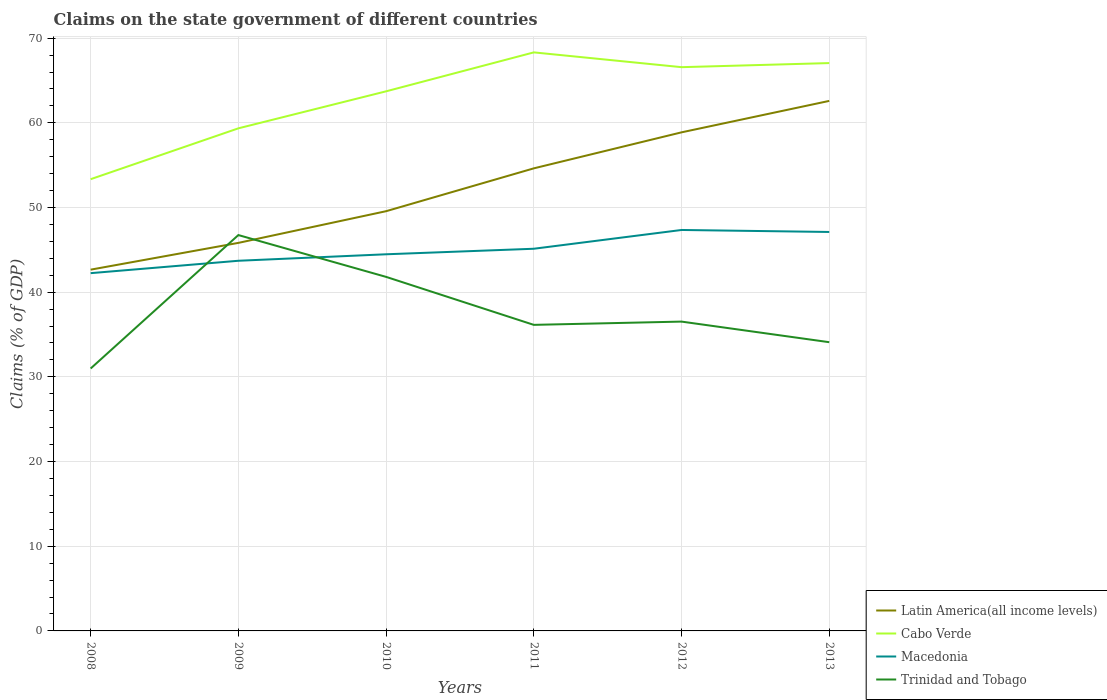Does the line corresponding to Trinidad and Tobago intersect with the line corresponding to Latin America(all income levels)?
Your response must be concise. Yes. Across all years, what is the maximum percentage of GDP claimed on the state government in Latin America(all income levels)?
Provide a succinct answer. 42.66. In which year was the percentage of GDP claimed on the state government in Macedonia maximum?
Give a very brief answer. 2008. What is the total percentage of GDP claimed on the state government in Cabo Verde in the graph?
Offer a very short reply. -14.98. What is the difference between the highest and the second highest percentage of GDP claimed on the state government in Trinidad and Tobago?
Offer a terse response. 15.76. How many years are there in the graph?
Keep it short and to the point. 6. What is the difference between two consecutive major ticks on the Y-axis?
Ensure brevity in your answer.  10. Are the values on the major ticks of Y-axis written in scientific E-notation?
Make the answer very short. No. Does the graph contain grids?
Provide a succinct answer. Yes. Where does the legend appear in the graph?
Your answer should be compact. Bottom right. How many legend labels are there?
Provide a short and direct response. 4. How are the legend labels stacked?
Provide a short and direct response. Vertical. What is the title of the graph?
Offer a very short reply. Claims on the state government of different countries. What is the label or title of the Y-axis?
Provide a succinct answer. Claims (% of GDP). What is the Claims (% of GDP) in Latin America(all income levels) in 2008?
Your response must be concise. 42.66. What is the Claims (% of GDP) of Cabo Verde in 2008?
Your answer should be compact. 53.34. What is the Claims (% of GDP) of Macedonia in 2008?
Provide a succinct answer. 42.25. What is the Claims (% of GDP) in Trinidad and Tobago in 2008?
Your answer should be very brief. 30.99. What is the Claims (% of GDP) of Latin America(all income levels) in 2009?
Your answer should be very brief. 45.82. What is the Claims (% of GDP) in Cabo Verde in 2009?
Offer a terse response. 59.35. What is the Claims (% of GDP) of Macedonia in 2009?
Your answer should be compact. 43.71. What is the Claims (% of GDP) in Trinidad and Tobago in 2009?
Give a very brief answer. 46.75. What is the Claims (% of GDP) in Latin America(all income levels) in 2010?
Ensure brevity in your answer.  49.56. What is the Claims (% of GDP) in Cabo Verde in 2010?
Provide a short and direct response. 63.72. What is the Claims (% of GDP) of Macedonia in 2010?
Provide a short and direct response. 44.48. What is the Claims (% of GDP) in Trinidad and Tobago in 2010?
Make the answer very short. 41.81. What is the Claims (% of GDP) of Latin America(all income levels) in 2011?
Your answer should be very brief. 54.62. What is the Claims (% of GDP) in Cabo Verde in 2011?
Offer a very short reply. 68.32. What is the Claims (% of GDP) in Macedonia in 2011?
Provide a short and direct response. 45.13. What is the Claims (% of GDP) in Trinidad and Tobago in 2011?
Make the answer very short. 36.14. What is the Claims (% of GDP) in Latin America(all income levels) in 2012?
Make the answer very short. 58.88. What is the Claims (% of GDP) of Cabo Verde in 2012?
Your answer should be compact. 66.57. What is the Claims (% of GDP) in Macedonia in 2012?
Provide a short and direct response. 47.35. What is the Claims (% of GDP) in Trinidad and Tobago in 2012?
Your answer should be very brief. 36.53. What is the Claims (% of GDP) of Latin America(all income levels) in 2013?
Give a very brief answer. 62.59. What is the Claims (% of GDP) of Cabo Verde in 2013?
Ensure brevity in your answer.  67.05. What is the Claims (% of GDP) in Macedonia in 2013?
Keep it short and to the point. 47.11. What is the Claims (% of GDP) in Trinidad and Tobago in 2013?
Keep it short and to the point. 34.09. Across all years, what is the maximum Claims (% of GDP) of Latin America(all income levels)?
Provide a short and direct response. 62.59. Across all years, what is the maximum Claims (% of GDP) of Cabo Verde?
Make the answer very short. 68.32. Across all years, what is the maximum Claims (% of GDP) in Macedonia?
Offer a very short reply. 47.35. Across all years, what is the maximum Claims (% of GDP) of Trinidad and Tobago?
Your response must be concise. 46.75. Across all years, what is the minimum Claims (% of GDP) of Latin America(all income levels)?
Ensure brevity in your answer.  42.66. Across all years, what is the minimum Claims (% of GDP) in Cabo Verde?
Ensure brevity in your answer.  53.34. Across all years, what is the minimum Claims (% of GDP) of Macedonia?
Offer a very short reply. 42.25. Across all years, what is the minimum Claims (% of GDP) in Trinidad and Tobago?
Give a very brief answer. 30.99. What is the total Claims (% of GDP) in Latin America(all income levels) in the graph?
Your response must be concise. 314.14. What is the total Claims (% of GDP) of Cabo Verde in the graph?
Keep it short and to the point. 378.35. What is the total Claims (% of GDP) of Macedonia in the graph?
Provide a succinct answer. 270.02. What is the total Claims (% of GDP) of Trinidad and Tobago in the graph?
Your answer should be compact. 226.3. What is the difference between the Claims (% of GDP) of Latin America(all income levels) in 2008 and that in 2009?
Your answer should be compact. -3.16. What is the difference between the Claims (% of GDP) in Cabo Verde in 2008 and that in 2009?
Offer a very short reply. -6.01. What is the difference between the Claims (% of GDP) of Macedonia in 2008 and that in 2009?
Offer a very short reply. -1.46. What is the difference between the Claims (% of GDP) in Trinidad and Tobago in 2008 and that in 2009?
Offer a terse response. -15.76. What is the difference between the Claims (% of GDP) in Latin America(all income levels) in 2008 and that in 2010?
Offer a very short reply. -6.9. What is the difference between the Claims (% of GDP) in Cabo Verde in 2008 and that in 2010?
Offer a very short reply. -10.38. What is the difference between the Claims (% of GDP) in Macedonia in 2008 and that in 2010?
Your response must be concise. -2.23. What is the difference between the Claims (% of GDP) in Trinidad and Tobago in 2008 and that in 2010?
Your answer should be compact. -10.82. What is the difference between the Claims (% of GDP) of Latin America(all income levels) in 2008 and that in 2011?
Give a very brief answer. -11.96. What is the difference between the Claims (% of GDP) of Cabo Verde in 2008 and that in 2011?
Provide a succinct answer. -14.98. What is the difference between the Claims (% of GDP) in Macedonia in 2008 and that in 2011?
Offer a terse response. -2.88. What is the difference between the Claims (% of GDP) of Trinidad and Tobago in 2008 and that in 2011?
Make the answer very short. -5.15. What is the difference between the Claims (% of GDP) in Latin America(all income levels) in 2008 and that in 2012?
Keep it short and to the point. -16.21. What is the difference between the Claims (% of GDP) in Cabo Verde in 2008 and that in 2012?
Offer a terse response. -13.23. What is the difference between the Claims (% of GDP) of Macedonia in 2008 and that in 2012?
Keep it short and to the point. -5.1. What is the difference between the Claims (% of GDP) of Trinidad and Tobago in 2008 and that in 2012?
Make the answer very short. -5.54. What is the difference between the Claims (% of GDP) in Latin America(all income levels) in 2008 and that in 2013?
Make the answer very short. -19.93. What is the difference between the Claims (% of GDP) of Cabo Verde in 2008 and that in 2013?
Your answer should be compact. -13.71. What is the difference between the Claims (% of GDP) in Macedonia in 2008 and that in 2013?
Offer a terse response. -4.86. What is the difference between the Claims (% of GDP) in Trinidad and Tobago in 2008 and that in 2013?
Your response must be concise. -3.11. What is the difference between the Claims (% of GDP) of Latin America(all income levels) in 2009 and that in 2010?
Offer a very short reply. -3.74. What is the difference between the Claims (% of GDP) in Cabo Verde in 2009 and that in 2010?
Your answer should be compact. -4.37. What is the difference between the Claims (% of GDP) in Macedonia in 2009 and that in 2010?
Keep it short and to the point. -0.77. What is the difference between the Claims (% of GDP) of Trinidad and Tobago in 2009 and that in 2010?
Make the answer very short. 4.94. What is the difference between the Claims (% of GDP) of Latin America(all income levels) in 2009 and that in 2011?
Provide a short and direct response. -8.8. What is the difference between the Claims (% of GDP) in Cabo Verde in 2009 and that in 2011?
Keep it short and to the point. -8.97. What is the difference between the Claims (% of GDP) of Macedonia in 2009 and that in 2011?
Provide a succinct answer. -1.42. What is the difference between the Claims (% of GDP) of Trinidad and Tobago in 2009 and that in 2011?
Provide a succinct answer. 10.6. What is the difference between the Claims (% of GDP) in Latin America(all income levels) in 2009 and that in 2012?
Make the answer very short. -13.05. What is the difference between the Claims (% of GDP) of Cabo Verde in 2009 and that in 2012?
Ensure brevity in your answer.  -7.22. What is the difference between the Claims (% of GDP) of Macedonia in 2009 and that in 2012?
Offer a terse response. -3.64. What is the difference between the Claims (% of GDP) in Trinidad and Tobago in 2009 and that in 2012?
Offer a terse response. 10.22. What is the difference between the Claims (% of GDP) in Latin America(all income levels) in 2009 and that in 2013?
Your answer should be compact. -16.77. What is the difference between the Claims (% of GDP) of Cabo Verde in 2009 and that in 2013?
Provide a succinct answer. -7.71. What is the difference between the Claims (% of GDP) of Macedonia in 2009 and that in 2013?
Keep it short and to the point. -3.4. What is the difference between the Claims (% of GDP) in Trinidad and Tobago in 2009 and that in 2013?
Your answer should be very brief. 12.65. What is the difference between the Claims (% of GDP) in Latin America(all income levels) in 2010 and that in 2011?
Your answer should be compact. -5.06. What is the difference between the Claims (% of GDP) of Cabo Verde in 2010 and that in 2011?
Give a very brief answer. -4.6. What is the difference between the Claims (% of GDP) of Macedonia in 2010 and that in 2011?
Keep it short and to the point. -0.65. What is the difference between the Claims (% of GDP) in Trinidad and Tobago in 2010 and that in 2011?
Provide a succinct answer. 5.67. What is the difference between the Claims (% of GDP) in Latin America(all income levels) in 2010 and that in 2012?
Offer a very short reply. -9.31. What is the difference between the Claims (% of GDP) of Cabo Verde in 2010 and that in 2012?
Provide a short and direct response. -2.85. What is the difference between the Claims (% of GDP) in Macedonia in 2010 and that in 2012?
Ensure brevity in your answer.  -2.87. What is the difference between the Claims (% of GDP) in Trinidad and Tobago in 2010 and that in 2012?
Keep it short and to the point. 5.28. What is the difference between the Claims (% of GDP) of Latin America(all income levels) in 2010 and that in 2013?
Ensure brevity in your answer.  -13.02. What is the difference between the Claims (% of GDP) in Cabo Verde in 2010 and that in 2013?
Give a very brief answer. -3.34. What is the difference between the Claims (% of GDP) of Macedonia in 2010 and that in 2013?
Offer a terse response. -2.63. What is the difference between the Claims (% of GDP) in Trinidad and Tobago in 2010 and that in 2013?
Provide a short and direct response. 7.71. What is the difference between the Claims (% of GDP) of Latin America(all income levels) in 2011 and that in 2012?
Your response must be concise. -4.25. What is the difference between the Claims (% of GDP) in Cabo Verde in 2011 and that in 2012?
Your answer should be very brief. 1.75. What is the difference between the Claims (% of GDP) in Macedonia in 2011 and that in 2012?
Provide a short and direct response. -2.22. What is the difference between the Claims (% of GDP) of Trinidad and Tobago in 2011 and that in 2012?
Offer a terse response. -0.39. What is the difference between the Claims (% of GDP) in Latin America(all income levels) in 2011 and that in 2013?
Keep it short and to the point. -7.97. What is the difference between the Claims (% of GDP) of Cabo Verde in 2011 and that in 2013?
Make the answer very short. 1.26. What is the difference between the Claims (% of GDP) of Macedonia in 2011 and that in 2013?
Offer a terse response. -1.98. What is the difference between the Claims (% of GDP) of Trinidad and Tobago in 2011 and that in 2013?
Keep it short and to the point. 2.05. What is the difference between the Claims (% of GDP) in Latin America(all income levels) in 2012 and that in 2013?
Make the answer very short. -3.71. What is the difference between the Claims (% of GDP) of Cabo Verde in 2012 and that in 2013?
Your response must be concise. -0.48. What is the difference between the Claims (% of GDP) in Macedonia in 2012 and that in 2013?
Give a very brief answer. 0.24. What is the difference between the Claims (% of GDP) in Trinidad and Tobago in 2012 and that in 2013?
Provide a succinct answer. 2.43. What is the difference between the Claims (% of GDP) in Latin America(all income levels) in 2008 and the Claims (% of GDP) in Cabo Verde in 2009?
Provide a short and direct response. -16.69. What is the difference between the Claims (% of GDP) of Latin America(all income levels) in 2008 and the Claims (% of GDP) of Macedonia in 2009?
Offer a very short reply. -1.05. What is the difference between the Claims (% of GDP) of Latin America(all income levels) in 2008 and the Claims (% of GDP) of Trinidad and Tobago in 2009?
Provide a short and direct response. -4.08. What is the difference between the Claims (% of GDP) in Cabo Verde in 2008 and the Claims (% of GDP) in Macedonia in 2009?
Provide a succinct answer. 9.63. What is the difference between the Claims (% of GDP) in Cabo Verde in 2008 and the Claims (% of GDP) in Trinidad and Tobago in 2009?
Your answer should be very brief. 6.6. What is the difference between the Claims (% of GDP) of Macedonia in 2008 and the Claims (% of GDP) of Trinidad and Tobago in 2009?
Make the answer very short. -4.5. What is the difference between the Claims (% of GDP) in Latin America(all income levels) in 2008 and the Claims (% of GDP) in Cabo Verde in 2010?
Make the answer very short. -21.06. What is the difference between the Claims (% of GDP) in Latin America(all income levels) in 2008 and the Claims (% of GDP) in Macedonia in 2010?
Make the answer very short. -1.82. What is the difference between the Claims (% of GDP) of Latin America(all income levels) in 2008 and the Claims (% of GDP) of Trinidad and Tobago in 2010?
Provide a short and direct response. 0.85. What is the difference between the Claims (% of GDP) in Cabo Verde in 2008 and the Claims (% of GDP) in Macedonia in 2010?
Keep it short and to the point. 8.87. What is the difference between the Claims (% of GDP) in Cabo Verde in 2008 and the Claims (% of GDP) in Trinidad and Tobago in 2010?
Make the answer very short. 11.53. What is the difference between the Claims (% of GDP) of Macedonia in 2008 and the Claims (% of GDP) of Trinidad and Tobago in 2010?
Your answer should be very brief. 0.44. What is the difference between the Claims (% of GDP) of Latin America(all income levels) in 2008 and the Claims (% of GDP) of Cabo Verde in 2011?
Make the answer very short. -25.66. What is the difference between the Claims (% of GDP) in Latin America(all income levels) in 2008 and the Claims (% of GDP) in Macedonia in 2011?
Keep it short and to the point. -2.47. What is the difference between the Claims (% of GDP) in Latin America(all income levels) in 2008 and the Claims (% of GDP) in Trinidad and Tobago in 2011?
Offer a terse response. 6.52. What is the difference between the Claims (% of GDP) of Cabo Verde in 2008 and the Claims (% of GDP) of Macedonia in 2011?
Give a very brief answer. 8.21. What is the difference between the Claims (% of GDP) of Cabo Verde in 2008 and the Claims (% of GDP) of Trinidad and Tobago in 2011?
Ensure brevity in your answer.  17.2. What is the difference between the Claims (% of GDP) of Macedonia in 2008 and the Claims (% of GDP) of Trinidad and Tobago in 2011?
Provide a succinct answer. 6.11. What is the difference between the Claims (% of GDP) of Latin America(all income levels) in 2008 and the Claims (% of GDP) of Cabo Verde in 2012?
Your response must be concise. -23.91. What is the difference between the Claims (% of GDP) in Latin America(all income levels) in 2008 and the Claims (% of GDP) in Macedonia in 2012?
Your answer should be very brief. -4.69. What is the difference between the Claims (% of GDP) in Latin America(all income levels) in 2008 and the Claims (% of GDP) in Trinidad and Tobago in 2012?
Offer a very short reply. 6.13. What is the difference between the Claims (% of GDP) in Cabo Verde in 2008 and the Claims (% of GDP) in Macedonia in 2012?
Keep it short and to the point. 6. What is the difference between the Claims (% of GDP) in Cabo Verde in 2008 and the Claims (% of GDP) in Trinidad and Tobago in 2012?
Your response must be concise. 16.81. What is the difference between the Claims (% of GDP) in Macedonia in 2008 and the Claims (% of GDP) in Trinidad and Tobago in 2012?
Offer a very short reply. 5.72. What is the difference between the Claims (% of GDP) in Latin America(all income levels) in 2008 and the Claims (% of GDP) in Cabo Verde in 2013?
Your answer should be compact. -24.39. What is the difference between the Claims (% of GDP) of Latin America(all income levels) in 2008 and the Claims (% of GDP) of Macedonia in 2013?
Offer a terse response. -4.45. What is the difference between the Claims (% of GDP) in Latin America(all income levels) in 2008 and the Claims (% of GDP) in Trinidad and Tobago in 2013?
Give a very brief answer. 8.57. What is the difference between the Claims (% of GDP) in Cabo Verde in 2008 and the Claims (% of GDP) in Macedonia in 2013?
Offer a terse response. 6.23. What is the difference between the Claims (% of GDP) of Cabo Verde in 2008 and the Claims (% of GDP) of Trinidad and Tobago in 2013?
Your answer should be compact. 19.25. What is the difference between the Claims (% of GDP) in Macedonia in 2008 and the Claims (% of GDP) in Trinidad and Tobago in 2013?
Your response must be concise. 8.15. What is the difference between the Claims (% of GDP) in Latin America(all income levels) in 2009 and the Claims (% of GDP) in Cabo Verde in 2010?
Your answer should be compact. -17.9. What is the difference between the Claims (% of GDP) of Latin America(all income levels) in 2009 and the Claims (% of GDP) of Macedonia in 2010?
Offer a very short reply. 1.35. What is the difference between the Claims (% of GDP) of Latin America(all income levels) in 2009 and the Claims (% of GDP) of Trinidad and Tobago in 2010?
Your answer should be compact. 4.01. What is the difference between the Claims (% of GDP) in Cabo Verde in 2009 and the Claims (% of GDP) in Macedonia in 2010?
Make the answer very short. 14.87. What is the difference between the Claims (% of GDP) of Cabo Verde in 2009 and the Claims (% of GDP) of Trinidad and Tobago in 2010?
Your response must be concise. 17.54. What is the difference between the Claims (% of GDP) in Macedonia in 2009 and the Claims (% of GDP) in Trinidad and Tobago in 2010?
Your answer should be very brief. 1.9. What is the difference between the Claims (% of GDP) of Latin America(all income levels) in 2009 and the Claims (% of GDP) of Cabo Verde in 2011?
Your answer should be compact. -22.5. What is the difference between the Claims (% of GDP) of Latin America(all income levels) in 2009 and the Claims (% of GDP) of Macedonia in 2011?
Make the answer very short. 0.69. What is the difference between the Claims (% of GDP) in Latin America(all income levels) in 2009 and the Claims (% of GDP) in Trinidad and Tobago in 2011?
Offer a very short reply. 9.68. What is the difference between the Claims (% of GDP) in Cabo Verde in 2009 and the Claims (% of GDP) in Macedonia in 2011?
Provide a short and direct response. 14.22. What is the difference between the Claims (% of GDP) of Cabo Verde in 2009 and the Claims (% of GDP) of Trinidad and Tobago in 2011?
Make the answer very short. 23.21. What is the difference between the Claims (% of GDP) in Macedonia in 2009 and the Claims (% of GDP) in Trinidad and Tobago in 2011?
Your answer should be compact. 7.57. What is the difference between the Claims (% of GDP) in Latin America(all income levels) in 2009 and the Claims (% of GDP) in Cabo Verde in 2012?
Your answer should be very brief. -20.75. What is the difference between the Claims (% of GDP) in Latin America(all income levels) in 2009 and the Claims (% of GDP) in Macedonia in 2012?
Offer a terse response. -1.52. What is the difference between the Claims (% of GDP) in Latin America(all income levels) in 2009 and the Claims (% of GDP) in Trinidad and Tobago in 2012?
Your answer should be very brief. 9.3. What is the difference between the Claims (% of GDP) in Cabo Verde in 2009 and the Claims (% of GDP) in Macedonia in 2012?
Make the answer very short. 12. What is the difference between the Claims (% of GDP) in Cabo Verde in 2009 and the Claims (% of GDP) in Trinidad and Tobago in 2012?
Provide a short and direct response. 22.82. What is the difference between the Claims (% of GDP) of Macedonia in 2009 and the Claims (% of GDP) of Trinidad and Tobago in 2012?
Offer a very short reply. 7.18. What is the difference between the Claims (% of GDP) in Latin America(all income levels) in 2009 and the Claims (% of GDP) in Cabo Verde in 2013?
Offer a very short reply. -21.23. What is the difference between the Claims (% of GDP) in Latin America(all income levels) in 2009 and the Claims (% of GDP) in Macedonia in 2013?
Provide a short and direct response. -1.29. What is the difference between the Claims (% of GDP) in Latin America(all income levels) in 2009 and the Claims (% of GDP) in Trinidad and Tobago in 2013?
Your answer should be compact. 11.73. What is the difference between the Claims (% of GDP) in Cabo Verde in 2009 and the Claims (% of GDP) in Macedonia in 2013?
Provide a succinct answer. 12.24. What is the difference between the Claims (% of GDP) of Cabo Verde in 2009 and the Claims (% of GDP) of Trinidad and Tobago in 2013?
Provide a succinct answer. 25.25. What is the difference between the Claims (% of GDP) in Macedonia in 2009 and the Claims (% of GDP) in Trinidad and Tobago in 2013?
Provide a succinct answer. 9.62. What is the difference between the Claims (% of GDP) in Latin America(all income levels) in 2010 and the Claims (% of GDP) in Cabo Verde in 2011?
Give a very brief answer. -18.75. What is the difference between the Claims (% of GDP) of Latin America(all income levels) in 2010 and the Claims (% of GDP) of Macedonia in 2011?
Your answer should be very brief. 4.43. What is the difference between the Claims (% of GDP) in Latin America(all income levels) in 2010 and the Claims (% of GDP) in Trinidad and Tobago in 2011?
Your response must be concise. 13.42. What is the difference between the Claims (% of GDP) of Cabo Verde in 2010 and the Claims (% of GDP) of Macedonia in 2011?
Keep it short and to the point. 18.59. What is the difference between the Claims (% of GDP) in Cabo Verde in 2010 and the Claims (% of GDP) in Trinidad and Tobago in 2011?
Give a very brief answer. 27.58. What is the difference between the Claims (% of GDP) of Macedonia in 2010 and the Claims (% of GDP) of Trinidad and Tobago in 2011?
Provide a short and direct response. 8.34. What is the difference between the Claims (% of GDP) in Latin America(all income levels) in 2010 and the Claims (% of GDP) in Cabo Verde in 2012?
Offer a very short reply. -17.01. What is the difference between the Claims (% of GDP) of Latin America(all income levels) in 2010 and the Claims (% of GDP) of Macedonia in 2012?
Offer a very short reply. 2.22. What is the difference between the Claims (% of GDP) of Latin America(all income levels) in 2010 and the Claims (% of GDP) of Trinidad and Tobago in 2012?
Offer a very short reply. 13.04. What is the difference between the Claims (% of GDP) of Cabo Verde in 2010 and the Claims (% of GDP) of Macedonia in 2012?
Your answer should be compact. 16.37. What is the difference between the Claims (% of GDP) in Cabo Verde in 2010 and the Claims (% of GDP) in Trinidad and Tobago in 2012?
Offer a very short reply. 27.19. What is the difference between the Claims (% of GDP) in Macedonia in 2010 and the Claims (% of GDP) in Trinidad and Tobago in 2012?
Provide a short and direct response. 7.95. What is the difference between the Claims (% of GDP) of Latin America(all income levels) in 2010 and the Claims (% of GDP) of Cabo Verde in 2013?
Offer a very short reply. -17.49. What is the difference between the Claims (% of GDP) of Latin America(all income levels) in 2010 and the Claims (% of GDP) of Macedonia in 2013?
Offer a very short reply. 2.45. What is the difference between the Claims (% of GDP) in Latin America(all income levels) in 2010 and the Claims (% of GDP) in Trinidad and Tobago in 2013?
Make the answer very short. 15.47. What is the difference between the Claims (% of GDP) of Cabo Verde in 2010 and the Claims (% of GDP) of Macedonia in 2013?
Your answer should be compact. 16.61. What is the difference between the Claims (% of GDP) of Cabo Verde in 2010 and the Claims (% of GDP) of Trinidad and Tobago in 2013?
Keep it short and to the point. 29.62. What is the difference between the Claims (% of GDP) in Macedonia in 2010 and the Claims (% of GDP) in Trinidad and Tobago in 2013?
Offer a terse response. 10.38. What is the difference between the Claims (% of GDP) of Latin America(all income levels) in 2011 and the Claims (% of GDP) of Cabo Verde in 2012?
Provide a succinct answer. -11.95. What is the difference between the Claims (% of GDP) of Latin America(all income levels) in 2011 and the Claims (% of GDP) of Macedonia in 2012?
Provide a succinct answer. 7.28. What is the difference between the Claims (% of GDP) in Latin America(all income levels) in 2011 and the Claims (% of GDP) in Trinidad and Tobago in 2012?
Provide a succinct answer. 18.1. What is the difference between the Claims (% of GDP) in Cabo Verde in 2011 and the Claims (% of GDP) in Macedonia in 2012?
Your answer should be compact. 20.97. What is the difference between the Claims (% of GDP) of Cabo Verde in 2011 and the Claims (% of GDP) of Trinidad and Tobago in 2012?
Your answer should be compact. 31.79. What is the difference between the Claims (% of GDP) of Macedonia in 2011 and the Claims (% of GDP) of Trinidad and Tobago in 2012?
Ensure brevity in your answer.  8.6. What is the difference between the Claims (% of GDP) of Latin America(all income levels) in 2011 and the Claims (% of GDP) of Cabo Verde in 2013?
Offer a terse response. -12.43. What is the difference between the Claims (% of GDP) in Latin America(all income levels) in 2011 and the Claims (% of GDP) in Macedonia in 2013?
Your response must be concise. 7.51. What is the difference between the Claims (% of GDP) of Latin America(all income levels) in 2011 and the Claims (% of GDP) of Trinidad and Tobago in 2013?
Keep it short and to the point. 20.53. What is the difference between the Claims (% of GDP) of Cabo Verde in 2011 and the Claims (% of GDP) of Macedonia in 2013?
Your response must be concise. 21.21. What is the difference between the Claims (% of GDP) in Cabo Verde in 2011 and the Claims (% of GDP) in Trinidad and Tobago in 2013?
Provide a succinct answer. 34.22. What is the difference between the Claims (% of GDP) in Macedonia in 2011 and the Claims (% of GDP) in Trinidad and Tobago in 2013?
Your response must be concise. 11.04. What is the difference between the Claims (% of GDP) in Latin America(all income levels) in 2012 and the Claims (% of GDP) in Cabo Verde in 2013?
Your answer should be very brief. -8.18. What is the difference between the Claims (% of GDP) in Latin America(all income levels) in 2012 and the Claims (% of GDP) in Macedonia in 2013?
Your response must be concise. 11.77. What is the difference between the Claims (% of GDP) of Latin America(all income levels) in 2012 and the Claims (% of GDP) of Trinidad and Tobago in 2013?
Provide a short and direct response. 24.78. What is the difference between the Claims (% of GDP) in Cabo Verde in 2012 and the Claims (% of GDP) in Macedonia in 2013?
Make the answer very short. 19.46. What is the difference between the Claims (% of GDP) of Cabo Verde in 2012 and the Claims (% of GDP) of Trinidad and Tobago in 2013?
Your response must be concise. 32.48. What is the difference between the Claims (% of GDP) in Macedonia in 2012 and the Claims (% of GDP) in Trinidad and Tobago in 2013?
Provide a short and direct response. 13.25. What is the average Claims (% of GDP) of Latin America(all income levels) per year?
Your answer should be compact. 52.36. What is the average Claims (% of GDP) of Cabo Verde per year?
Provide a succinct answer. 63.06. What is the average Claims (% of GDP) of Macedonia per year?
Your response must be concise. 45. What is the average Claims (% of GDP) of Trinidad and Tobago per year?
Your answer should be very brief. 37.72. In the year 2008, what is the difference between the Claims (% of GDP) in Latin America(all income levels) and Claims (% of GDP) in Cabo Verde?
Provide a short and direct response. -10.68. In the year 2008, what is the difference between the Claims (% of GDP) in Latin America(all income levels) and Claims (% of GDP) in Macedonia?
Ensure brevity in your answer.  0.41. In the year 2008, what is the difference between the Claims (% of GDP) of Latin America(all income levels) and Claims (% of GDP) of Trinidad and Tobago?
Provide a short and direct response. 11.67. In the year 2008, what is the difference between the Claims (% of GDP) in Cabo Verde and Claims (% of GDP) in Macedonia?
Offer a terse response. 11.09. In the year 2008, what is the difference between the Claims (% of GDP) in Cabo Verde and Claims (% of GDP) in Trinidad and Tobago?
Your answer should be compact. 22.35. In the year 2008, what is the difference between the Claims (% of GDP) of Macedonia and Claims (% of GDP) of Trinidad and Tobago?
Your response must be concise. 11.26. In the year 2009, what is the difference between the Claims (% of GDP) of Latin America(all income levels) and Claims (% of GDP) of Cabo Verde?
Your answer should be very brief. -13.53. In the year 2009, what is the difference between the Claims (% of GDP) in Latin America(all income levels) and Claims (% of GDP) in Macedonia?
Provide a short and direct response. 2.11. In the year 2009, what is the difference between the Claims (% of GDP) of Latin America(all income levels) and Claims (% of GDP) of Trinidad and Tobago?
Ensure brevity in your answer.  -0.92. In the year 2009, what is the difference between the Claims (% of GDP) of Cabo Verde and Claims (% of GDP) of Macedonia?
Ensure brevity in your answer.  15.64. In the year 2009, what is the difference between the Claims (% of GDP) of Cabo Verde and Claims (% of GDP) of Trinidad and Tobago?
Make the answer very short. 12.6. In the year 2009, what is the difference between the Claims (% of GDP) in Macedonia and Claims (% of GDP) in Trinidad and Tobago?
Offer a very short reply. -3.04. In the year 2010, what is the difference between the Claims (% of GDP) of Latin America(all income levels) and Claims (% of GDP) of Cabo Verde?
Your response must be concise. -14.15. In the year 2010, what is the difference between the Claims (% of GDP) in Latin America(all income levels) and Claims (% of GDP) in Macedonia?
Provide a short and direct response. 5.09. In the year 2010, what is the difference between the Claims (% of GDP) in Latin America(all income levels) and Claims (% of GDP) in Trinidad and Tobago?
Give a very brief answer. 7.76. In the year 2010, what is the difference between the Claims (% of GDP) of Cabo Verde and Claims (% of GDP) of Macedonia?
Offer a terse response. 19.24. In the year 2010, what is the difference between the Claims (% of GDP) of Cabo Verde and Claims (% of GDP) of Trinidad and Tobago?
Offer a very short reply. 21.91. In the year 2010, what is the difference between the Claims (% of GDP) of Macedonia and Claims (% of GDP) of Trinidad and Tobago?
Make the answer very short. 2.67. In the year 2011, what is the difference between the Claims (% of GDP) of Latin America(all income levels) and Claims (% of GDP) of Cabo Verde?
Your answer should be very brief. -13.69. In the year 2011, what is the difference between the Claims (% of GDP) of Latin America(all income levels) and Claims (% of GDP) of Macedonia?
Your answer should be very brief. 9.49. In the year 2011, what is the difference between the Claims (% of GDP) of Latin America(all income levels) and Claims (% of GDP) of Trinidad and Tobago?
Provide a succinct answer. 18.48. In the year 2011, what is the difference between the Claims (% of GDP) of Cabo Verde and Claims (% of GDP) of Macedonia?
Offer a terse response. 23.19. In the year 2011, what is the difference between the Claims (% of GDP) of Cabo Verde and Claims (% of GDP) of Trinidad and Tobago?
Offer a terse response. 32.18. In the year 2011, what is the difference between the Claims (% of GDP) of Macedonia and Claims (% of GDP) of Trinidad and Tobago?
Your response must be concise. 8.99. In the year 2012, what is the difference between the Claims (% of GDP) in Latin America(all income levels) and Claims (% of GDP) in Cabo Verde?
Keep it short and to the point. -7.7. In the year 2012, what is the difference between the Claims (% of GDP) in Latin America(all income levels) and Claims (% of GDP) in Macedonia?
Give a very brief answer. 11.53. In the year 2012, what is the difference between the Claims (% of GDP) of Latin America(all income levels) and Claims (% of GDP) of Trinidad and Tobago?
Give a very brief answer. 22.35. In the year 2012, what is the difference between the Claims (% of GDP) of Cabo Verde and Claims (% of GDP) of Macedonia?
Provide a succinct answer. 19.22. In the year 2012, what is the difference between the Claims (% of GDP) in Cabo Verde and Claims (% of GDP) in Trinidad and Tobago?
Your response must be concise. 30.04. In the year 2012, what is the difference between the Claims (% of GDP) of Macedonia and Claims (% of GDP) of Trinidad and Tobago?
Your answer should be very brief. 10.82. In the year 2013, what is the difference between the Claims (% of GDP) in Latin America(all income levels) and Claims (% of GDP) in Cabo Verde?
Provide a succinct answer. -4.47. In the year 2013, what is the difference between the Claims (% of GDP) in Latin America(all income levels) and Claims (% of GDP) in Macedonia?
Ensure brevity in your answer.  15.48. In the year 2013, what is the difference between the Claims (% of GDP) of Latin America(all income levels) and Claims (% of GDP) of Trinidad and Tobago?
Give a very brief answer. 28.49. In the year 2013, what is the difference between the Claims (% of GDP) in Cabo Verde and Claims (% of GDP) in Macedonia?
Keep it short and to the point. 19.95. In the year 2013, what is the difference between the Claims (% of GDP) of Cabo Verde and Claims (% of GDP) of Trinidad and Tobago?
Your response must be concise. 32.96. In the year 2013, what is the difference between the Claims (% of GDP) in Macedonia and Claims (% of GDP) in Trinidad and Tobago?
Ensure brevity in your answer.  13.02. What is the ratio of the Claims (% of GDP) of Latin America(all income levels) in 2008 to that in 2009?
Offer a very short reply. 0.93. What is the ratio of the Claims (% of GDP) of Cabo Verde in 2008 to that in 2009?
Your answer should be very brief. 0.9. What is the ratio of the Claims (% of GDP) in Macedonia in 2008 to that in 2009?
Provide a succinct answer. 0.97. What is the ratio of the Claims (% of GDP) of Trinidad and Tobago in 2008 to that in 2009?
Your answer should be compact. 0.66. What is the ratio of the Claims (% of GDP) in Latin America(all income levels) in 2008 to that in 2010?
Ensure brevity in your answer.  0.86. What is the ratio of the Claims (% of GDP) of Cabo Verde in 2008 to that in 2010?
Make the answer very short. 0.84. What is the ratio of the Claims (% of GDP) in Macedonia in 2008 to that in 2010?
Offer a very short reply. 0.95. What is the ratio of the Claims (% of GDP) of Trinidad and Tobago in 2008 to that in 2010?
Your answer should be compact. 0.74. What is the ratio of the Claims (% of GDP) in Latin America(all income levels) in 2008 to that in 2011?
Offer a very short reply. 0.78. What is the ratio of the Claims (% of GDP) of Cabo Verde in 2008 to that in 2011?
Give a very brief answer. 0.78. What is the ratio of the Claims (% of GDP) of Macedonia in 2008 to that in 2011?
Your answer should be compact. 0.94. What is the ratio of the Claims (% of GDP) of Trinidad and Tobago in 2008 to that in 2011?
Give a very brief answer. 0.86. What is the ratio of the Claims (% of GDP) in Latin America(all income levels) in 2008 to that in 2012?
Ensure brevity in your answer.  0.72. What is the ratio of the Claims (% of GDP) in Cabo Verde in 2008 to that in 2012?
Your response must be concise. 0.8. What is the ratio of the Claims (% of GDP) of Macedonia in 2008 to that in 2012?
Your answer should be very brief. 0.89. What is the ratio of the Claims (% of GDP) in Trinidad and Tobago in 2008 to that in 2012?
Offer a terse response. 0.85. What is the ratio of the Claims (% of GDP) of Latin America(all income levels) in 2008 to that in 2013?
Your answer should be very brief. 0.68. What is the ratio of the Claims (% of GDP) of Cabo Verde in 2008 to that in 2013?
Make the answer very short. 0.8. What is the ratio of the Claims (% of GDP) of Macedonia in 2008 to that in 2013?
Your response must be concise. 0.9. What is the ratio of the Claims (% of GDP) in Trinidad and Tobago in 2008 to that in 2013?
Your response must be concise. 0.91. What is the ratio of the Claims (% of GDP) in Latin America(all income levels) in 2009 to that in 2010?
Make the answer very short. 0.92. What is the ratio of the Claims (% of GDP) in Cabo Verde in 2009 to that in 2010?
Ensure brevity in your answer.  0.93. What is the ratio of the Claims (% of GDP) of Macedonia in 2009 to that in 2010?
Provide a succinct answer. 0.98. What is the ratio of the Claims (% of GDP) in Trinidad and Tobago in 2009 to that in 2010?
Offer a terse response. 1.12. What is the ratio of the Claims (% of GDP) in Latin America(all income levels) in 2009 to that in 2011?
Give a very brief answer. 0.84. What is the ratio of the Claims (% of GDP) in Cabo Verde in 2009 to that in 2011?
Give a very brief answer. 0.87. What is the ratio of the Claims (% of GDP) in Macedonia in 2009 to that in 2011?
Your response must be concise. 0.97. What is the ratio of the Claims (% of GDP) of Trinidad and Tobago in 2009 to that in 2011?
Provide a succinct answer. 1.29. What is the ratio of the Claims (% of GDP) of Latin America(all income levels) in 2009 to that in 2012?
Provide a succinct answer. 0.78. What is the ratio of the Claims (% of GDP) in Cabo Verde in 2009 to that in 2012?
Ensure brevity in your answer.  0.89. What is the ratio of the Claims (% of GDP) of Macedonia in 2009 to that in 2012?
Provide a short and direct response. 0.92. What is the ratio of the Claims (% of GDP) of Trinidad and Tobago in 2009 to that in 2012?
Your response must be concise. 1.28. What is the ratio of the Claims (% of GDP) in Latin America(all income levels) in 2009 to that in 2013?
Your answer should be very brief. 0.73. What is the ratio of the Claims (% of GDP) of Cabo Verde in 2009 to that in 2013?
Ensure brevity in your answer.  0.89. What is the ratio of the Claims (% of GDP) of Macedonia in 2009 to that in 2013?
Make the answer very short. 0.93. What is the ratio of the Claims (% of GDP) in Trinidad and Tobago in 2009 to that in 2013?
Offer a very short reply. 1.37. What is the ratio of the Claims (% of GDP) of Latin America(all income levels) in 2010 to that in 2011?
Provide a short and direct response. 0.91. What is the ratio of the Claims (% of GDP) of Cabo Verde in 2010 to that in 2011?
Offer a very short reply. 0.93. What is the ratio of the Claims (% of GDP) of Macedonia in 2010 to that in 2011?
Your answer should be very brief. 0.99. What is the ratio of the Claims (% of GDP) in Trinidad and Tobago in 2010 to that in 2011?
Make the answer very short. 1.16. What is the ratio of the Claims (% of GDP) in Latin America(all income levels) in 2010 to that in 2012?
Provide a succinct answer. 0.84. What is the ratio of the Claims (% of GDP) in Cabo Verde in 2010 to that in 2012?
Ensure brevity in your answer.  0.96. What is the ratio of the Claims (% of GDP) in Macedonia in 2010 to that in 2012?
Keep it short and to the point. 0.94. What is the ratio of the Claims (% of GDP) in Trinidad and Tobago in 2010 to that in 2012?
Keep it short and to the point. 1.14. What is the ratio of the Claims (% of GDP) in Latin America(all income levels) in 2010 to that in 2013?
Provide a succinct answer. 0.79. What is the ratio of the Claims (% of GDP) of Cabo Verde in 2010 to that in 2013?
Offer a very short reply. 0.95. What is the ratio of the Claims (% of GDP) of Macedonia in 2010 to that in 2013?
Provide a succinct answer. 0.94. What is the ratio of the Claims (% of GDP) in Trinidad and Tobago in 2010 to that in 2013?
Give a very brief answer. 1.23. What is the ratio of the Claims (% of GDP) in Latin America(all income levels) in 2011 to that in 2012?
Keep it short and to the point. 0.93. What is the ratio of the Claims (% of GDP) of Cabo Verde in 2011 to that in 2012?
Your answer should be very brief. 1.03. What is the ratio of the Claims (% of GDP) in Macedonia in 2011 to that in 2012?
Keep it short and to the point. 0.95. What is the ratio of the Claims (% of GDP) in Latin America(all income levels) in 2011 to that in 2013?
Your answer should be very brief. 0.87. What is the ratio of the Claims (% of GDP) in Cabo Verde in 2011 to that in 2013?
Offer a very short reply. 1.02. What is the ratio of the Claims (% of GDP) in Macedonia in 2011 to that in 2013?
Provide a short and direct response. 0.96. What is the ratio of the Claims (% of GDP) of Trinidad and Tobago in 2011 to that in 2013?
Give a very brief answer. 1.06. What is the ratio of the Claims (% of GDP) in Latin America(all income levels) in 2012 to that in 2013?
Offer a terse response. 0.94. What is the ratio of the Claims (% of GDP) of Cabo Verde in 2012 to that in 2013?
Offer a terse response. 0.99. What is the ratio of the Claims (% of GDP) of Macedonia in 2012 to that in 2013?
Make the answer very short. 1. What is the ratio of the Claims (% of GDP) of Trinidad and Tobago in 2012 to that in 2013?
Offer a terse response. 1.07. What is the difference between the highest and the second highest Claims (% of GDP) of Latin America(all income levels)?
Your answer should be very brief. 3.71. What is the difference between the highest and the second highest Claims (% of GDP) of Cabo Verde?
Your response must be concise. 1.26. What is the difference between the highest and the second highest Claims (% of GDP) in Macedonia?
Give a very brief answer. 0.24. What is the difference between the highest and the second highest Claims (% of GDP) of Trinidad and Tobago?
Ensure brevity in your answer.  4.94. What is the difference between the highest and the lowest Claims (% of GDP) of Latin America(all income levels)?
Your answer should be very brief. 19.93. What is the difference between the highest and the lowest Claims (% of GDP) of Cabo Verde?
Provide a succinct answer. 14.98. What is the difference between the highest and the lowest Claims (% of GDP) of Macedonia?
Your answer should be compact. 5.1. What is the difference between the highest and the lowest Claims (% of GDP) in Trinidad and Tobago?
Provide a succinct answer. 15.76. 